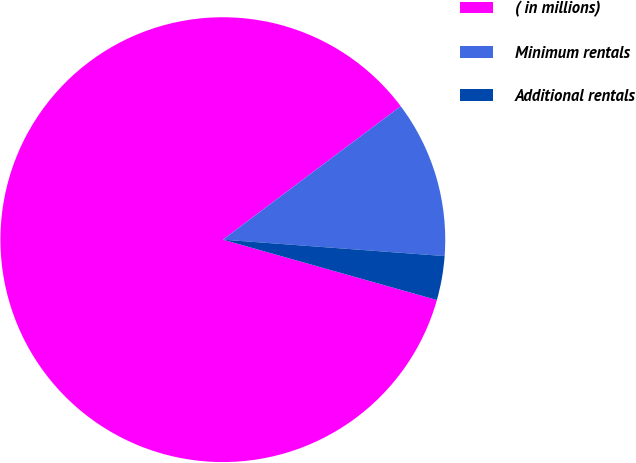Convert chart. <chart><loc_0><loc_0><loc_500><loc_500><pie_chart><fcel>( in millions)<fcel>Minimum rentals<fcel>Additional rentals<nl><fcel>85.38%<fcel>11.42%<fcel>3.2%<nl></chart> 